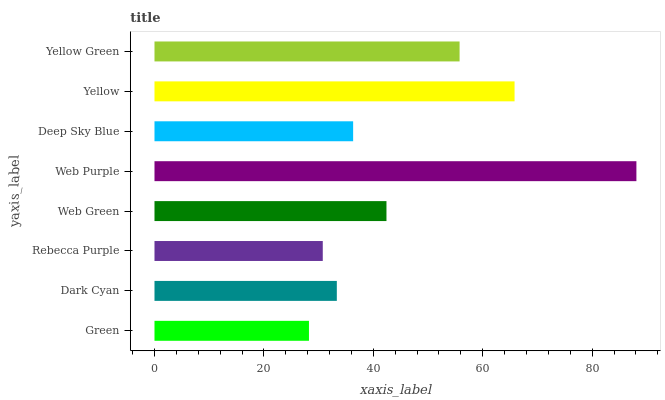Is Green the minimum?
Answer yes or no. Yes. Is Web Purple the maximum?
Answer yes or no. Yes. Is Dark Cyan the minimum?
Answer yes or no. No. Is Dark Cyan the maximum?
Answer yes or no. No. Is Dark Cyan greater than Green?
Answer yes or no. Yes. Is Green less than Dark Cyan?
Answer yes or no. Yes. Is Green greater than Dark Cyan?
Answer yes or no. No. Is Dark Cyan less than Green?
Answer yes or no. No. Is Web Green the high median?
Answer yes or no. Yes. Is Deep Sky Blue the low median?
Answer yes or no. Yes. Is Green the high median?
Answer yes or no. No. Is Web Purple the low median?
Answer yes or no. No. 